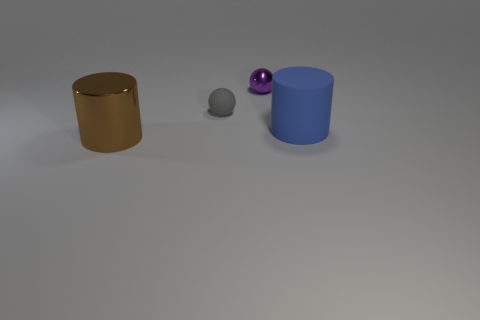Add 2 gray matte objects. How many objects exist? 6 Subtract 1 cylinders. How many cylinders are left? 1 Subtract all gray cylinders. Subtract all green cubes. How many cylinders are left? 2 Subtract all red cylinders. How many gray balls are left? 1 Subtract all big purple objects. Subtract all gray objects. How many objects are left? 3 Add 1 gray rubber things. How many gray rubber things are left? 2 Add 4 tiny gray things. How many tiny gray things exist? 5 Subtract 0 red cylinders. How many objects are left? 4 